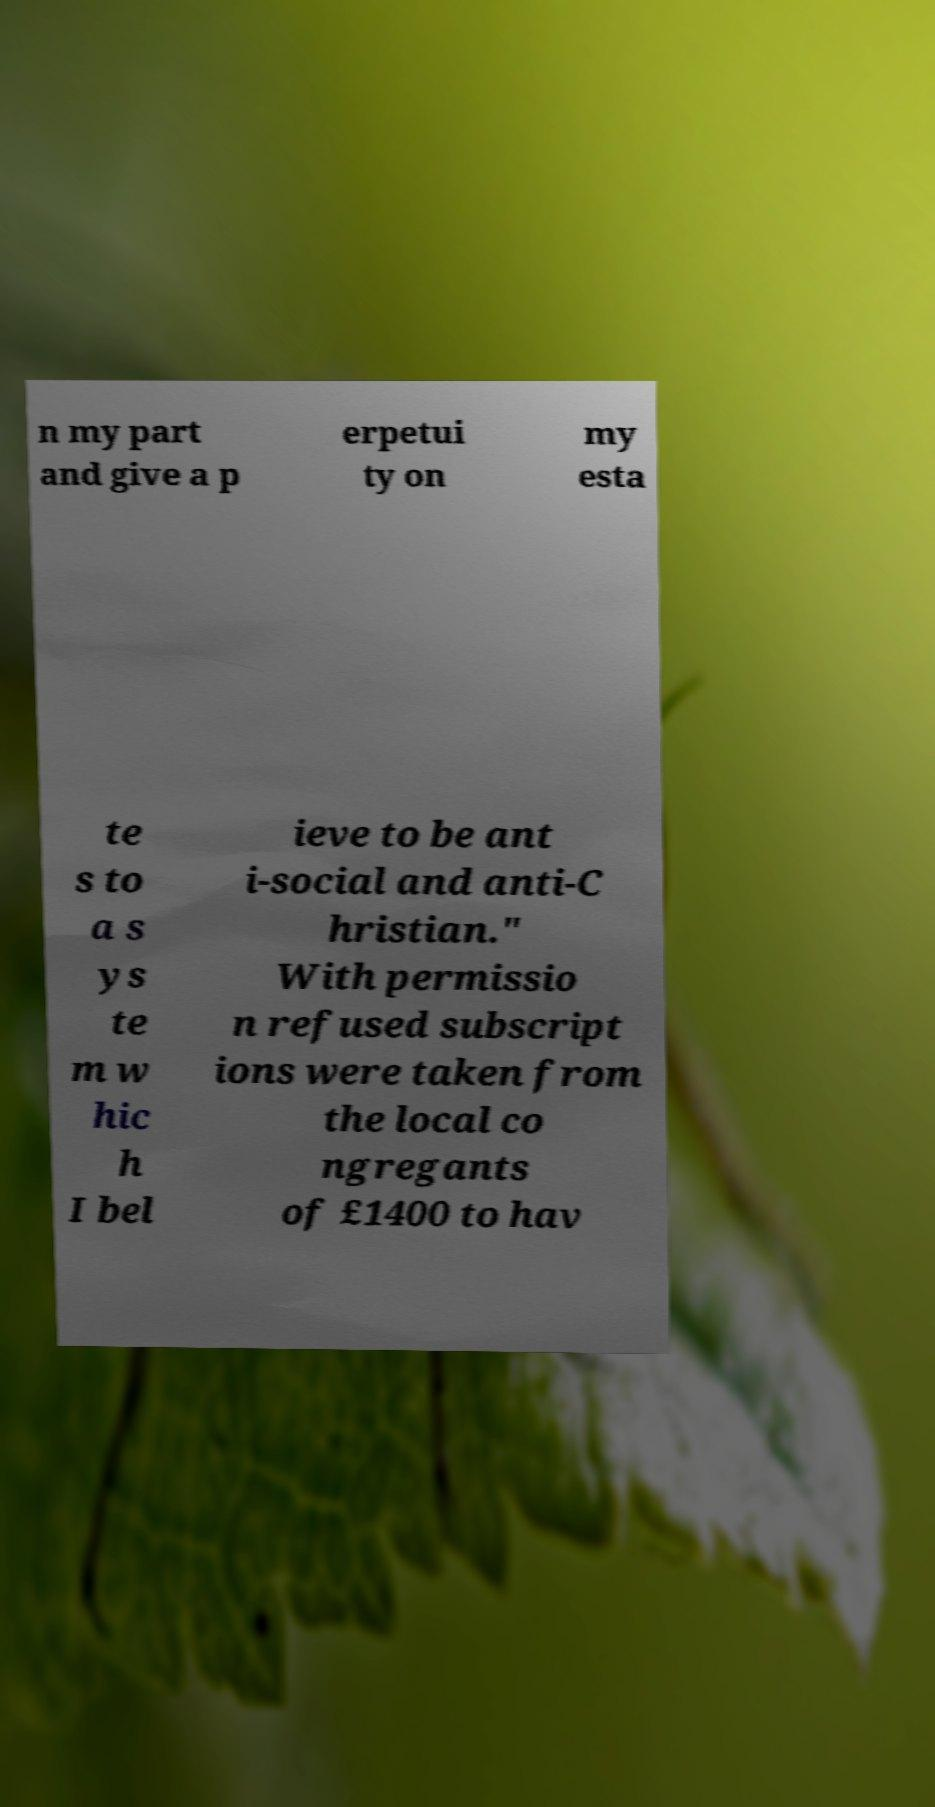There's text embedded in this image that I need extracted. Can you transcribe it verbatim? n my part and give a p erpetui ty on my esta te s to a s ys te m w hic h I bel ieve to be ant i-social and anti-C hristian." With permissio n refused subscript ions were taken from the local co ngregants of £1400 to hav 